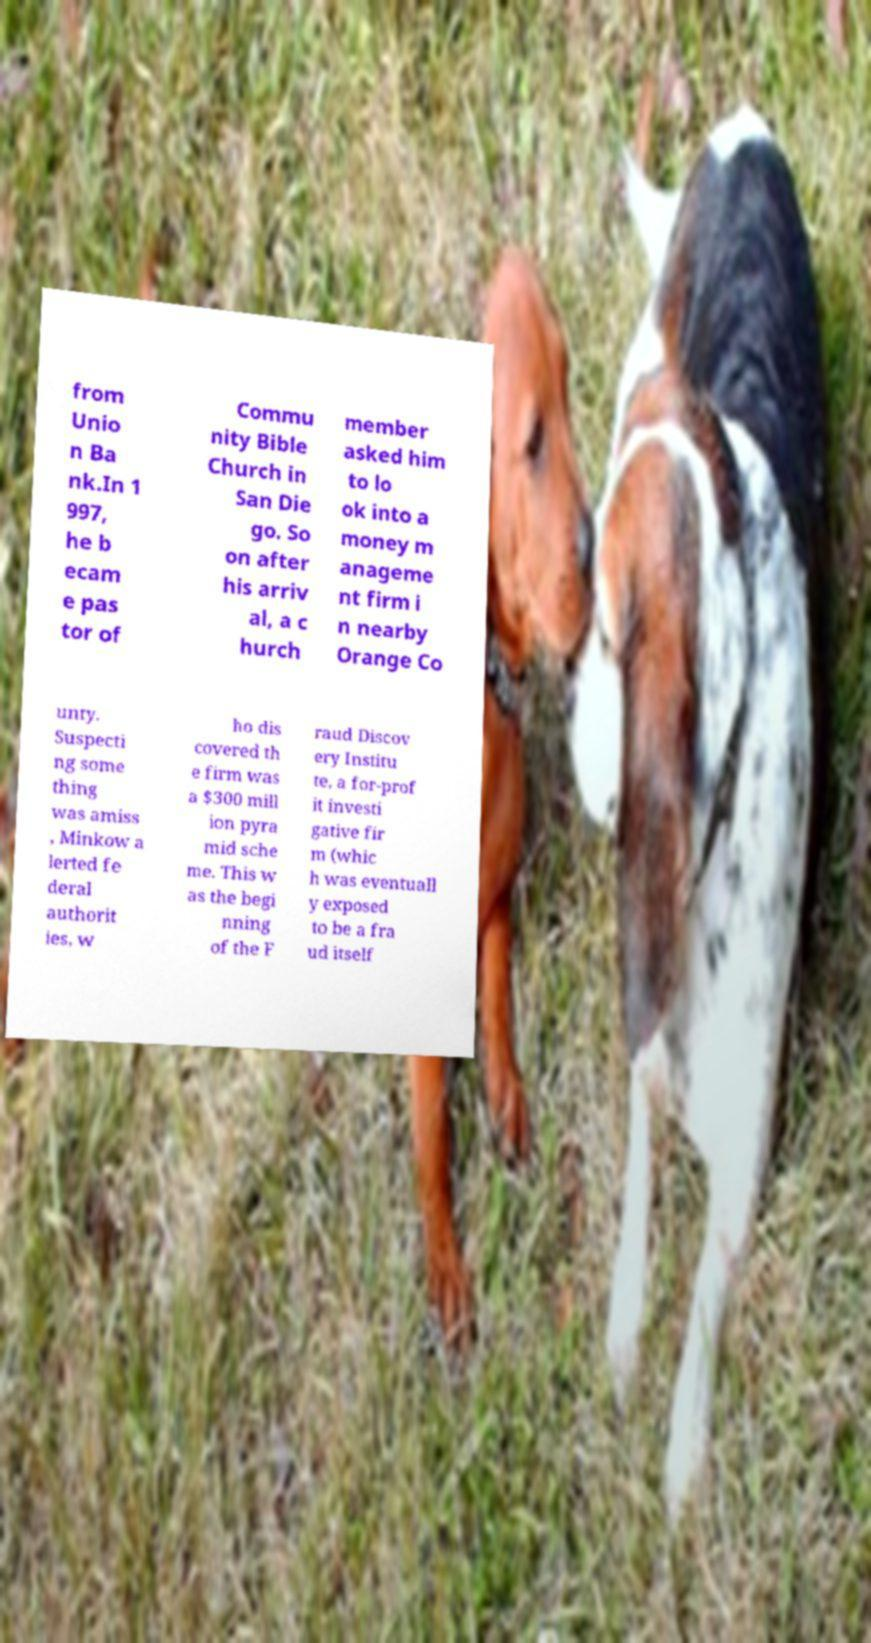Please read and relay the text visible in this image. What does it say? from Unio n Ba nk.In 1 997, he b ecam e pas tor of Commu nity Bible Church in San Die go. So on after his arriv al, a c hurch member asked him to lo ok into a money m anageme nt firm i n nearby Orange Co unty. Suspecti ng some thing was amiss , Minkow a lerted fe deral authorit ies, w ho dis covered th e firm was a $300 mill ion pyra mid sche me. This w as the begi nning of the F raud Discov ery Institu te, a for-prof it investi gative fir m (whic h was eventuall y exposed to be a fra ud itself 